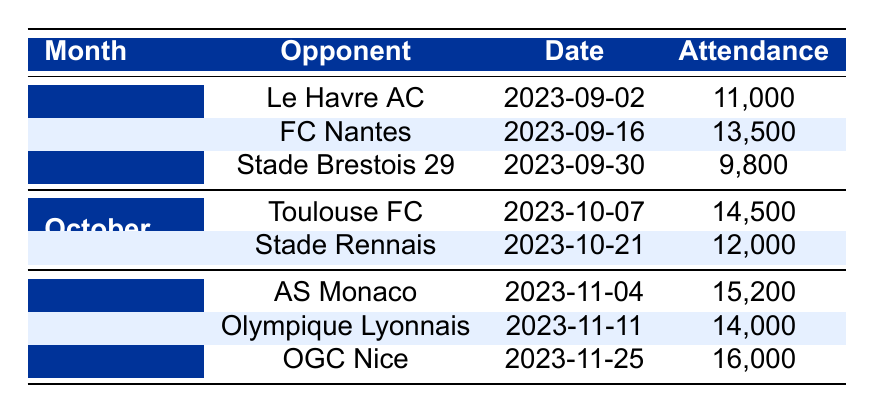What is the total attendance in September? To find the total attendance for September, we add the attendance figures for all matches that took place in that month: 11,000 (Le Havre AC) + 13,500 (FC Nantes) + 9,800 (Stade Brestois 29) = 34,300.
Answer: 34,300 Which opponent had the highest attendance? We compare the attendance figures for all matches in the table. The highest attendance is 16,000 for OGC Nice on November 25.
Answer: OGC Nice Was there a match with an attendance of more than 15,000 in October? Looking at the October matches, we see 14,500 for Toulouse FC and 12,000 for Stade Rennais; neither exceeds 15,000.
Answer: No How many matches were played in November? By reviewing the table, we note that there are three matches listed in November: AS Monaco, Olympique Lyonnais, and OGC Nice.
Answer: 3 What is the average attendance for matches in September? To find the average attendance for September, we first calculate the total attendance (34,300 from the previous answer) and divide by the number of matches (3): 34,300 / 3 = 11,433.33.
Answer: 11,433.33 Did SC Bastia play against FC Nantes? Checking the opponent column, FC Nantes is mentioned as an opponent, but it doesn't specify that SC Bastia played against them; hence we assume the match was played on a separate occasion.
Answer: No Which month had the highest individual match attendance? Reviewing individual match figures, November has the highest single attendance with 16,000 for OGC Nice.
Answer: November What was the attendance difference between the match against AS Monaco and the match against Stade Rennais? The attendance for AS Monaco was 15,200, and for Stade Rennais, it was 12,000. Calculating the difference: 15,200 - 12,000 = 3,200.
Answer: 3,200 